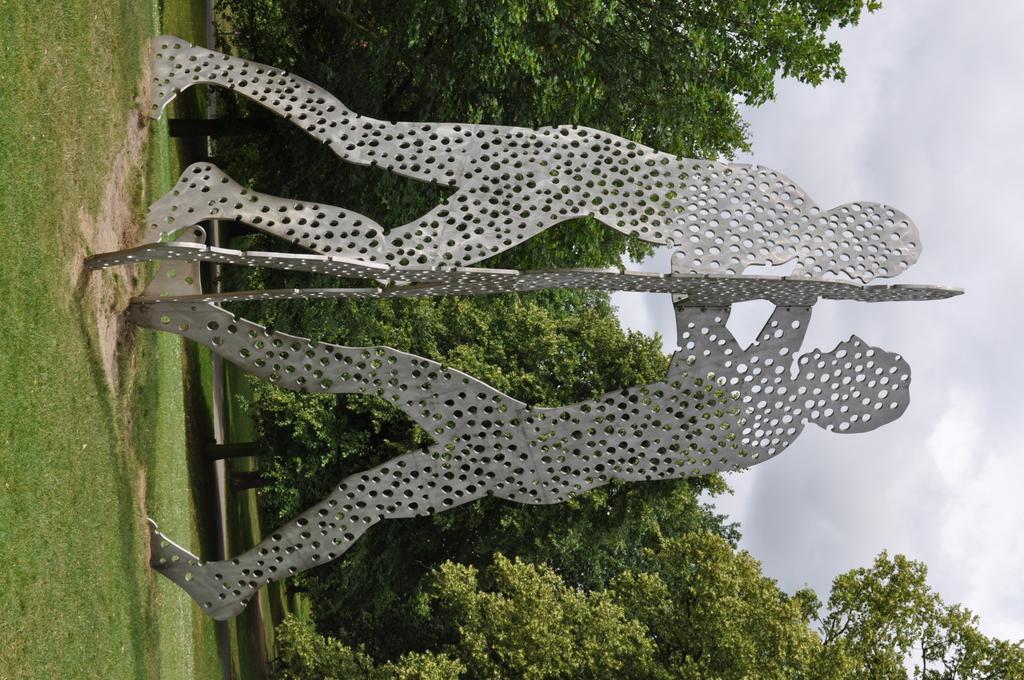How would you summarize this image in a sentence or two? In this picture we can see sculptures on the grass, in the background we can see few trees. 